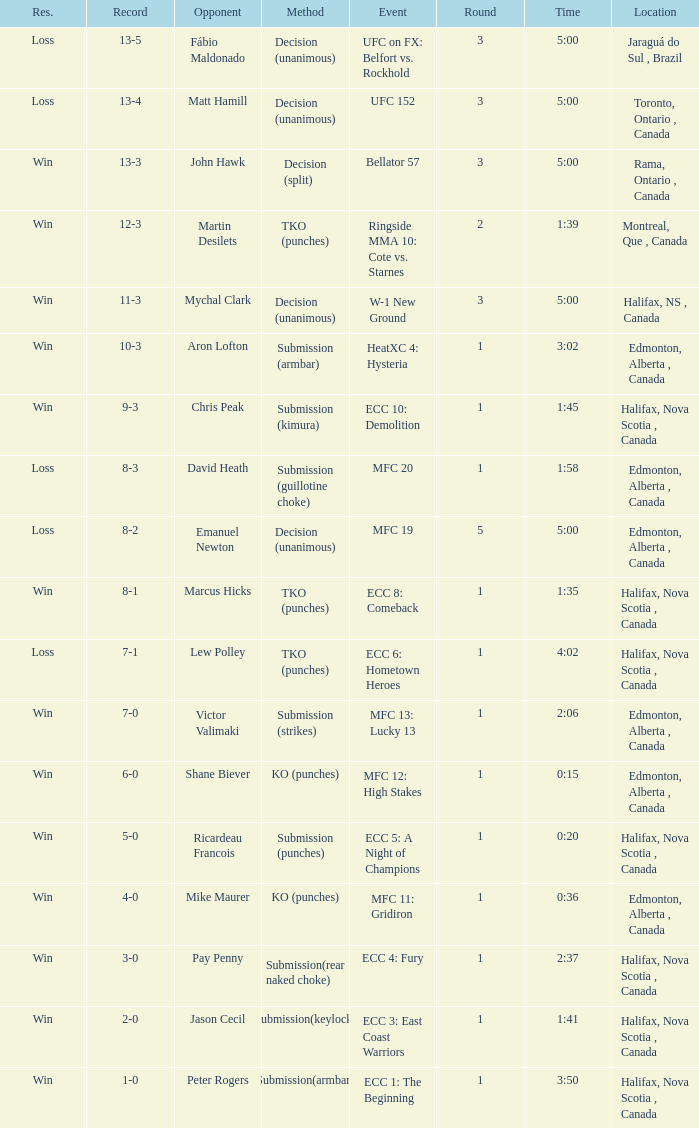What is the round of the match with Emanuel Newton as the opponent? 5.0. 